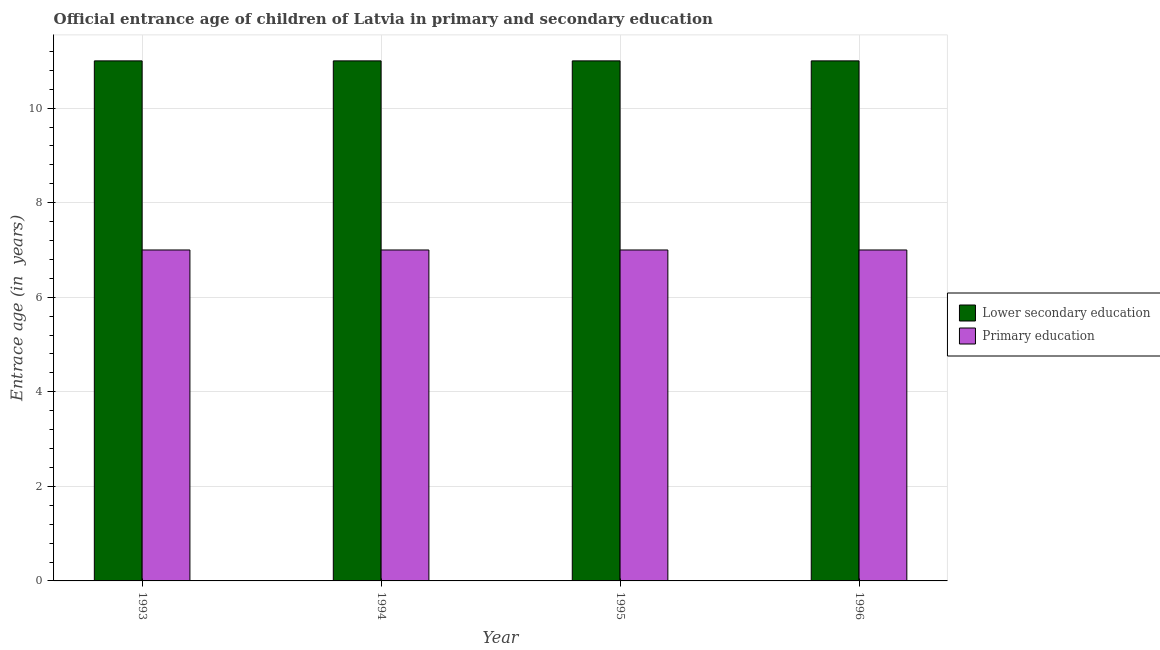How many different coloured bars are there?
Provide a short and direct response. 2. Are the number of bars on each tick of the X-axis equal?
Provide a succinct answer. Yes. How many bars are there on the 3rd tick from the right?
Your answer should be very brief. 2. What is the label of the 3rd group of bars from the left?
Provide a short and direct response. 1995. In how many cases, is the number of bars for a given year not equal to the number of legend labels?
Keep it short and to the point. 0. What is the entrance age of children in lower secondary education in 1994?
Give a very brief answer. 11. Across all years, what is the maximum entrance age of chiildren in primary education?
Keep it short and to the point. 7. Across all years, what is the minimum entrance age of chiildren in primary education?
Your response must be concise. 7. In which year was the entrance age of children in lower secondary education maximum?
Your answer should be compact. 1993. What is the total entrance age of chiildren in primary education in the graph?
Offer a terse response. 28. What is the difference between the entrance age of children in lower secondary education in 1994 and that in 1996?
Make the answer very short. 0. What is the difference between the entrance age of children in lower secondary education in 1994 and the entrance age of chiildren in primary education in 1993?
Offer a terse response. 0. What is the average entrance age of children in lower secondary education per year?
Your response must be concise. 11. Is the entrance age of chiildren in primary education in 1993 less than that in 1995?
Your response must be concise. No. In how many years, is the entrance age of chiildren in primary education greater than the average entrance age of chiildren in primary education taken over all years?
Your response must be concise. 0. What does the 1st bar from the left in 1993 represents?
Your answer should be compact. Lower secondary education. What does the 2nd bar from the right in 1994 represents?
Your answer should be compact. Lower secondary education. Does the graph contain grids?
Provide a succinct answer. Yes. How many legend labels are there?
Ensure brevity in your answer.  2. How are the legend labels stacked?
Offer a terse response. Vertical. What is the title of the graph?
Offer a terse response. Official entrance age of children of Latvia in primary and secondary education. What is the label or title of the Y-axis?
Make the answer very short. Entrace age (in  years). What is the Entrace age (in  years) in Primary education in 1994?
Keep it short and to the point. 7. What is the Entrace age (in  years) in Primary education in 1995?
Your answer should be compact. 7. What is the Entrace age (in  years) in Lower secondary education in 1996?
Give a very brief answer. 11. What is the Entrace age (in  years) of Primary education in 1996?
Offer a very short reply. 7. Across all years, what is the minimum Entrace age (in  years) of Lower secondary education?
Provide a succinct answer. 11. What is the total Entrace age (in  years) in Lower secondary education in the graph?
Your answer should be very brief. 44. What is the difference between the Entrace age (in  years) in Primary education in 1993 and that in 1994?
Give a very brief answer. 0. What is the difference between the Entrace age (in  years) of Lower secondary education in 1993 and that in 1996?
Make the answer very short. 0. What is the difference between the Entrace age (in  years) in Primary education in 1993 and that in 1996?
Offer a terse response. 0. What is the difference between the Entrace age (in  years) in Lower secondary education in 1994 and that in 1995?
Your answer should be compact. 0. What is the difference between the Entrace age (in  years) of Primary education in 1995 and that in 1996?
Ensure brevity in your answer.  0. What is the difference between the Entrace age (in  years) of Lower secondary education in 1994 and the Entrace age (in  years) of Primary education in 1996?
Provide a short and direct response. 4. In the year 1996, what is the difference between the Entrace age (in  years) in Lower secondary education and Entrace age (in  years) in Primary education?
Provide a short and direct response. 4. What is the ratio of the Entrace age (in  years) in Lower secondary education in 1993 to that in 1995?
Keep it short and to the point. 1. What is the ratio of the Entrace age (in  years) of Primary education in 1993 to that in 1995?
Offer a very short reply. 1. What is the ratio of the Entrace age (in  years) of Lower secondary education in 1993 to that in 1996?
Give a very brief answer. 1. What is the ratio of the Entrace age (in  years) of Lower secondary education in 1994 to that in 1995?
Offer a very short reply. 1. What is the ratio of the Entrace age (in  years) of Primary education in 1994 to that in 1995?
Make the answer very short. 1. What is the ratio of the Entrace age (in  years) of Primary education in 1994 to that in 1996?
Keep it short and to the point. 1. What is the ratio of the Entrace age (in  years) in Lower secondary education in 1995 to that in 1996?
Offer a very short reply. 1. What is the difference between the highest and the second highest Entrace age (in  years) of Lower secondary education?
Provide a short and direct response. 0. What is the difference between the highest and the second highest Entrace age (in  years) of Primary education?
Offer a very short reply. 0. What is the difference between the highest and the lowest Entrace age (in  years) in Lower secondary education?
Provide a succinct answer. 0. 